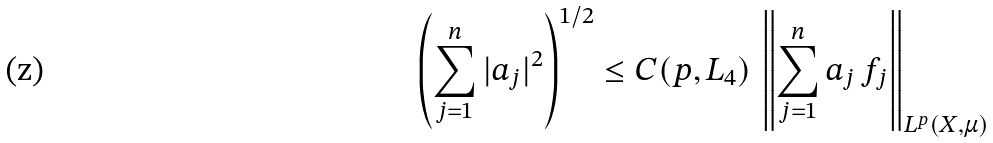<formula> <loc_0><loc_0><loc_500><loc_500>\left ( \sum _ { j = 1 } ^ { n } | a _ { j } | ^ { 2 } \right ) ^ { 1 / 2 } \leq C ( p , L _ { 4 } ) \, \left \| \sum _ { j = 1 } ^ { n } a _ { j } \, f _ { j } \right \| _ { L ^ { p } ( X , \mu ) }</formula> 